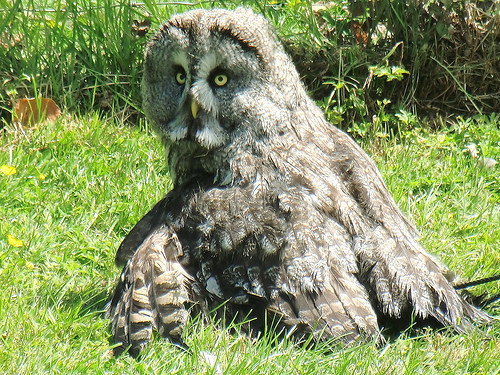<image>
Is the owl in the grass? Yes. The owl is contained within or inside the grass, showing a containment relationship. 